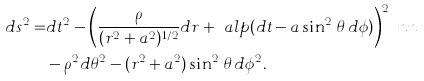Convert formula to latex. <formula><loc_0><loc_0><loc_500><loc_500>d s ^ { 2 } = & d t ^ { 2 } - \left ( \frac { \rho } { ( r ^ { 2 } + a ^ { 2 } ) ^ { 1 / 2 } } d r + \ a l p ( d t - a \sin ^ { 2 } \, \theta \, d \phi ) \right ) ^ { 2 } \ n n \\ & - \rho ^ { 2 } d \theta ^ { 2 } - ( r ^ { 2 } + a ^ { 2 } ) \sin ^ { 2 } \, \theta \, d \phi ^ { 2 } .</formula> 